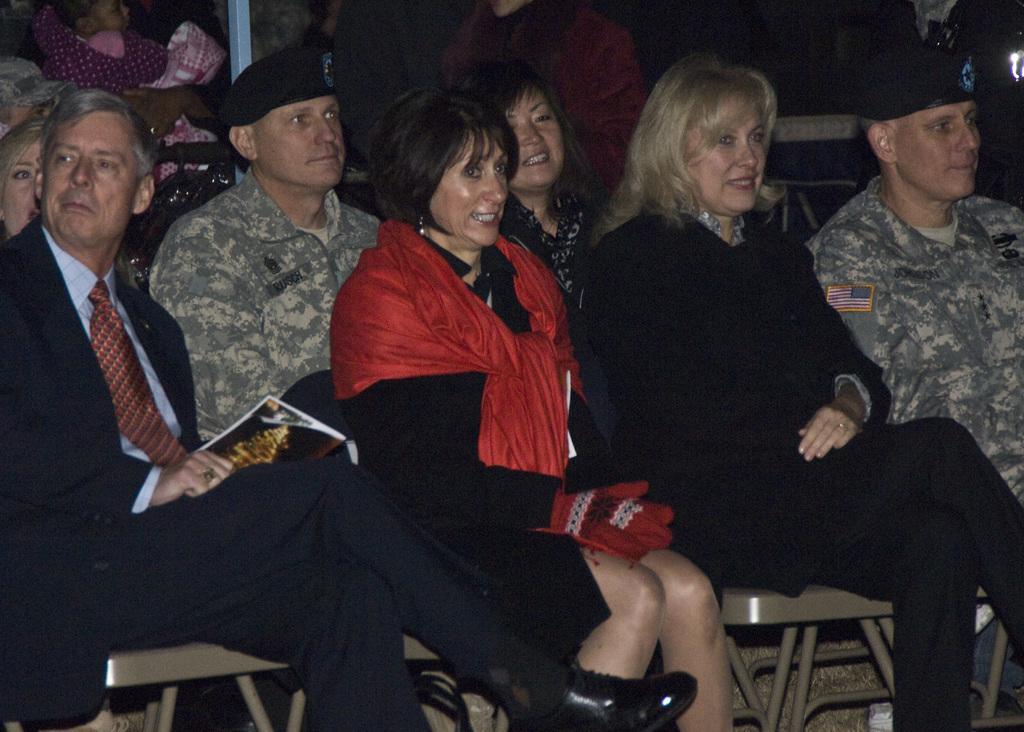In one or two sentences, can you explain what this image depicts? In the picture there are soldiers and some other people who are sitting, the women who are sitting in the first two rows are laughing , behind them there are also few other people. 